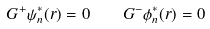<formula> <loc_0><loc_0><loc_500><loc_500>G ^ { + } \psi ^ { * } _ { n } ( { r } ) = 0 \quad G ^ { - } \phi ^ { * } _ { n } ( { r } ) = 0</formula> 